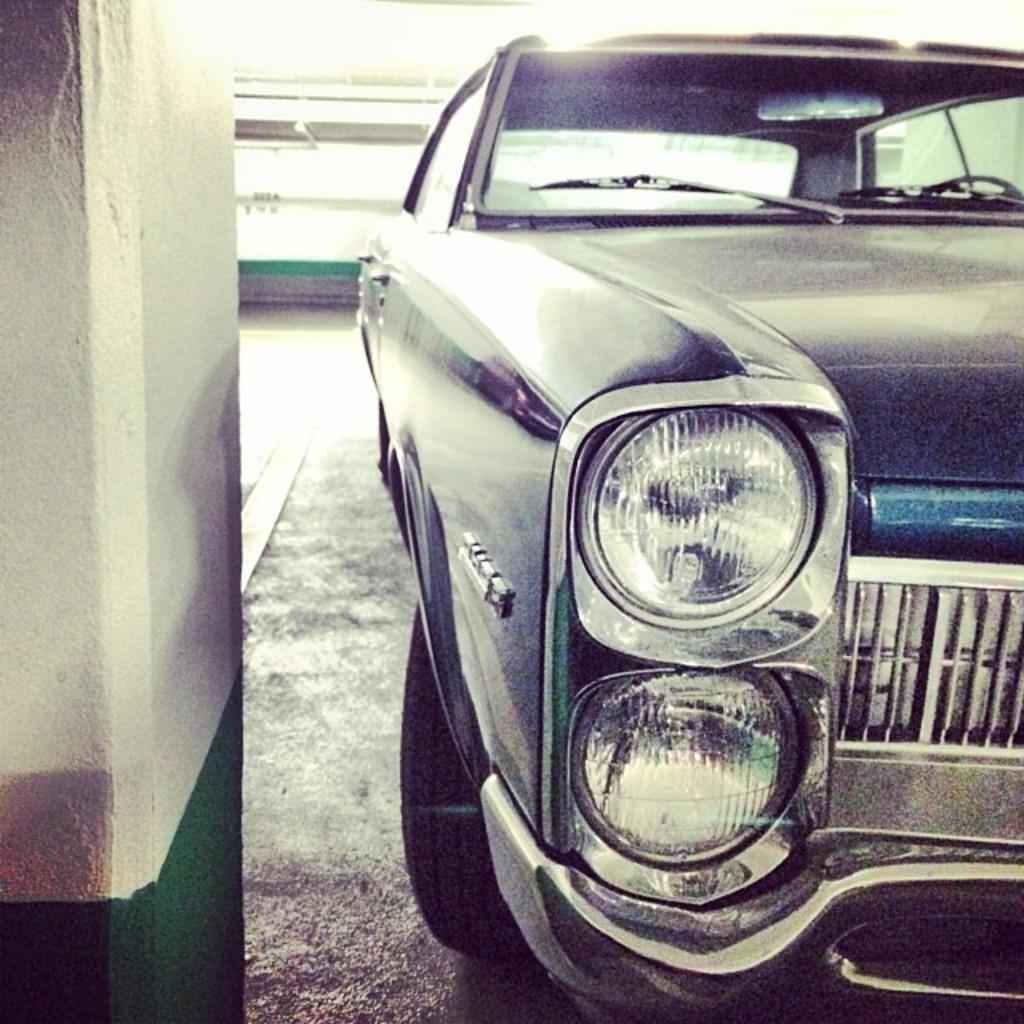Could you give a brief overview of what you see in this image? In this image we can see a car placed on the surface. On the left side we can see a pillar. On the backside we can see a wall. 